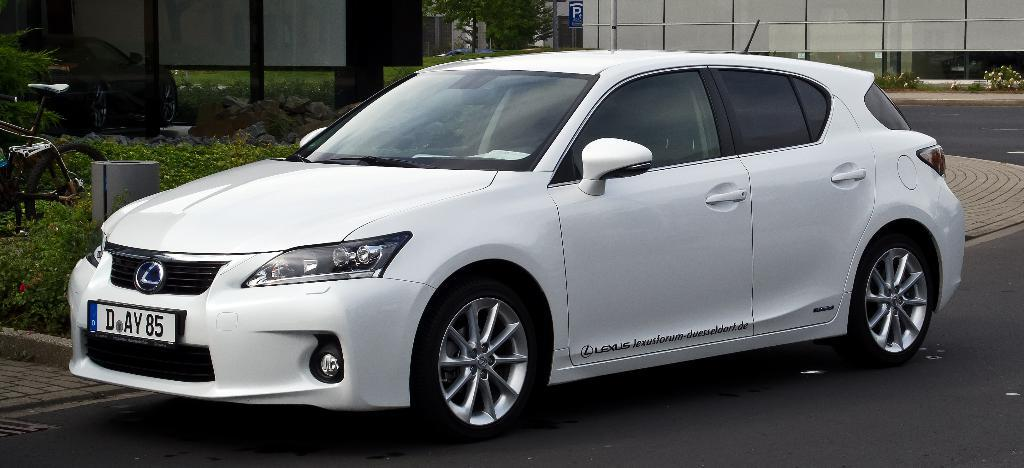What type of vehicle is on the road in the image? There is a white car on the road in the image. What other mode of transportation can be seen in the image? There is a bicycle in the image. What natural elements are present in the image? Plants and stones are present in the image. What man-made object can be seen providing information or direction? There is a signboard in the image. What type of structure is visible in the background? There is a wall in the image. How many toes can be seen on the baby in the image? There is no baby present in the image, so it is not possible to determine the number of toes. What achievement is the achiever celebrating in the image? There is no achiever or celebration depicted in the image. 